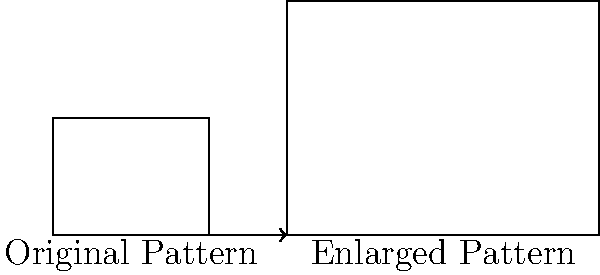A traditional geometric pattern from your region is being enlarged for a cultural exhibition. The original pattern is a rectangle measuring 4 units wide and 3 units tall. If the enlarged version is 14 units wide, what is the scaling factor used for the enlargement? To find the scaling factor, we need to compare the dimensions of the enlarged pattern to the original pattern. Let's follow these steps:

1) We know the original width is 4 units and the enlarged width is 14 units.

2) The scaling factor is the ratio of the new size to the original size. We can express this mathematically as:

   $$ \text{Scaling Factor} = \frac{\text{New Size}}{\text{Original Size}} $$

3) Using the width dimensions:

   $$ \text{Scaling Factor} = \frac{14 \text{ units}}{4 \text{ units}} $$

4) Simplify the fraction:

   $$ \text{Scaling Factor} = \frac{14}{4} = \frac{7}{2} = 3.5 $$

5) We can verify this by checking the height:
   - Original height: 3 units
   - Enlarged height: $3 \times 3.5 = 10.5$ units

Therefore, the scaling factor used for enlarging the cultural pattern is 3.5.
Answer: 3.5 